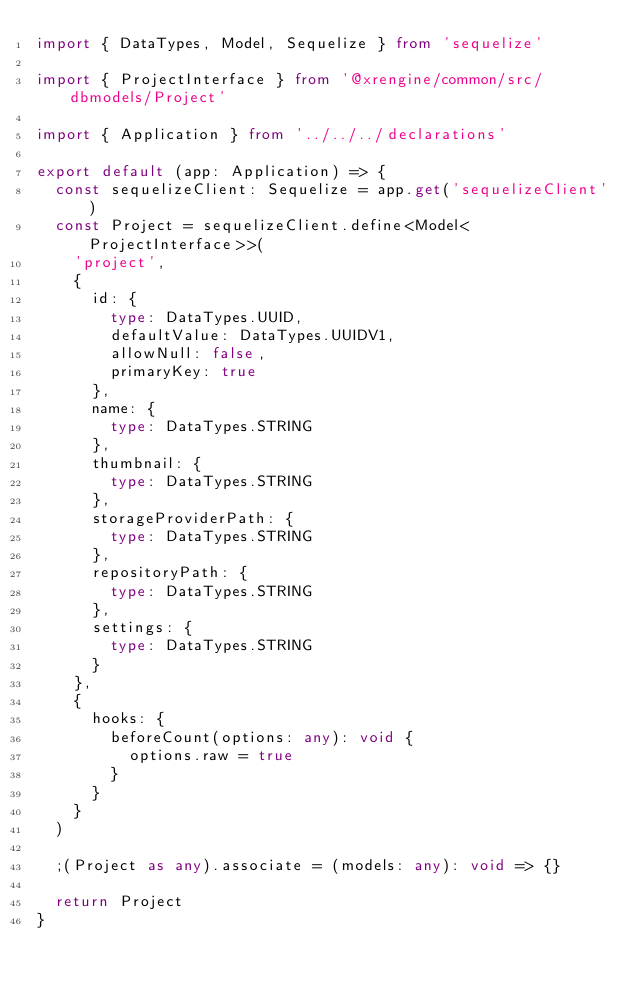Convert code to text. <code><loc_0><loc_0><loc_500><loc_500><_TypeScript_>import { DataTypes, Model, Sequelize } from 'sequelize'

import { ProjectInterface } from '@xrengine/common/src/dbmodels/Project'

import { Application } from '../../../declarations'

export default (app: Application) => {
  const sequelizeClient: Sequelize = app.get('sequelizeClient')
  const Project = sequelizeClient.define<Model<ProjectInterface>>(
    'project',
    {
      id: {
        type: DataTypes.UUID,
        defaultValue: DataTypes.UUIDV1,
        allowNull: false,
        primaryKey: true
      },
      name: {
        type: DataTypes.STRING
      },
      thumbnail: {
        type: DataTypes.STRING
      },
      storageProviderPath: {
        type: DataTypes.STRING
      },
      repositoryPath: {
        type: DataTypes.STRING
      },
      settings: {
        type: DataTypes.STRING
      }
    },
    {
      hooks: {
        beforeCount(options: any): void {
          options.raw = true
        }
      }
    }
  )

  ;(Project as any).associate = (models: any): void => {}

  return Project
}
</code> 